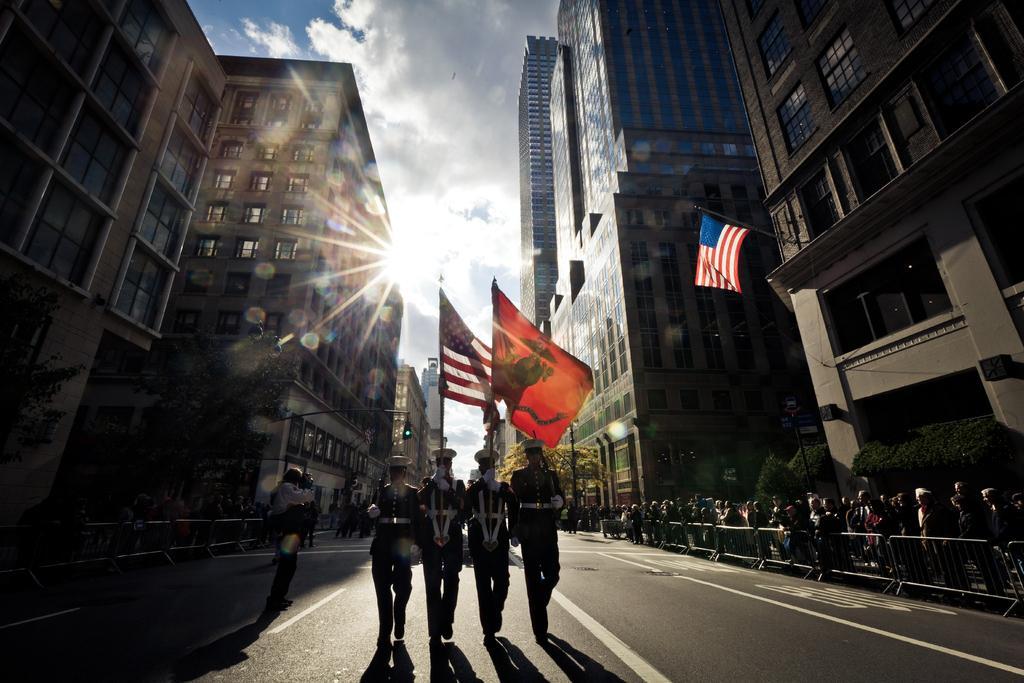Please provide a concise description of this image. In the center of the image we can see persons walking on the road holding flags. On the right side of the image we can see buildings, persons, fencing, trees and flag. On the left side of the image we can see buildings and trees. In the background we can see sky and clouds. 